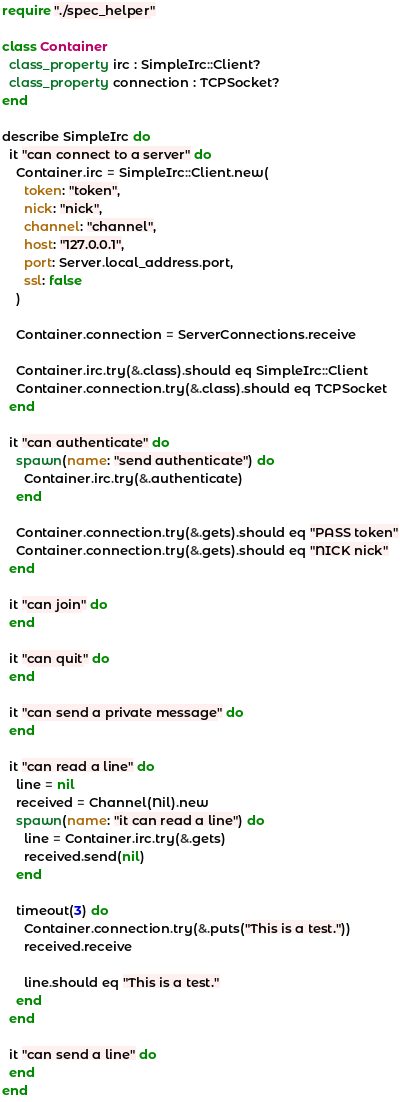<code> <loc_0><loc_0><loc_500><loc_500><_Crystal_>require "./spec_helper"

class Container
  class_property irc : SimpleIrc::Client?
  class_property connection : TCPSocket?
end

describe SimpleIrc do
  it "can connect to a server" do
    Container.irc = SimpleIrc::Client.new(
      token: "token",
      nick: "nick",
      channel: "channel",
      host: "127.0.0.1",
      port: Server.local_address.port,
      ssl: false
    )

    Container.connection = ServerConnections.receive

    Container.irc.try(&.class).should eq SimpleIrc::Client
    Container.connection.try(&.class).should eq TCPSocket
  end

  it "can authenticate" do
    spawn(name: "send authenticate") do
      Container.irc.try(&.authenticate)
    end

    Container.connection.try(&.gets).should eq "PASS token"
    Container.connection.try(&.gets).should eq "NICK nick"
  end

  it "can join" do
  end

  it "can quit" do
  end

  it "can send a private message" do
  end

  it "can read a line" do
    line = nil
    received = Channel(Nil).new
    spawn(name: "it can read a line") do
      line = Container.irc.try(&.gets)
      received.send(nil)
    end

    timeout(3) do
      Container.connection.try(&.puts("This is a test."))
      received.receive

      line.should eq "This is a test."
    end
  end

  it "can send a line" do
  end
end
</code> 